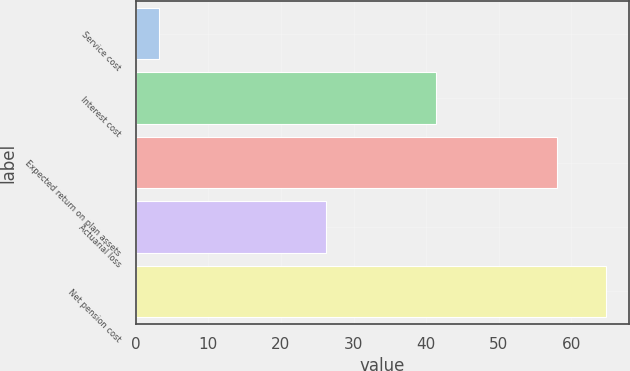Convert chart to OTSL. <chart><loc_0><loc_0><loc_500><loc_500><bar_chart><fcel>Service cost<fcel>Interest cost<fcel>Expected return on plan assets<fcel>Actuarial loss<fcel>Net pension cost<nl><fcel>3.2<fcel>41.3<fcel>58<fcel>26.2<fcel>64.7<nl></chart> 